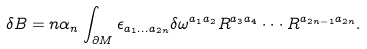<formula> <loc_0><loc_0><loc_500><loc_500>\delta B = n \alpha _ { n } \int _ { \partial M } \epsilon _ { a _ { 1 } \dots a _ { 2 n } } \delta \omega ^ { a _ { 1 } a _ { 2 } } R ^ { a _ { 3 } a _ { 4 } } \cdot \cdot \cdot R ^ { a _ { 2 n - 1 } a _ { 2 n } } .</formula> 